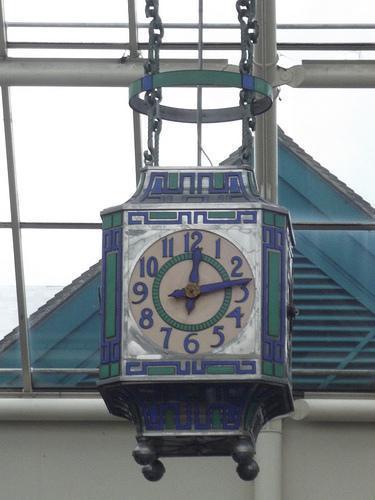How many hands does the clock have?
Give a very brief answer. 2. How many balls are at the bottom of th clocks' structure?
Give a very brief answer. 4. 